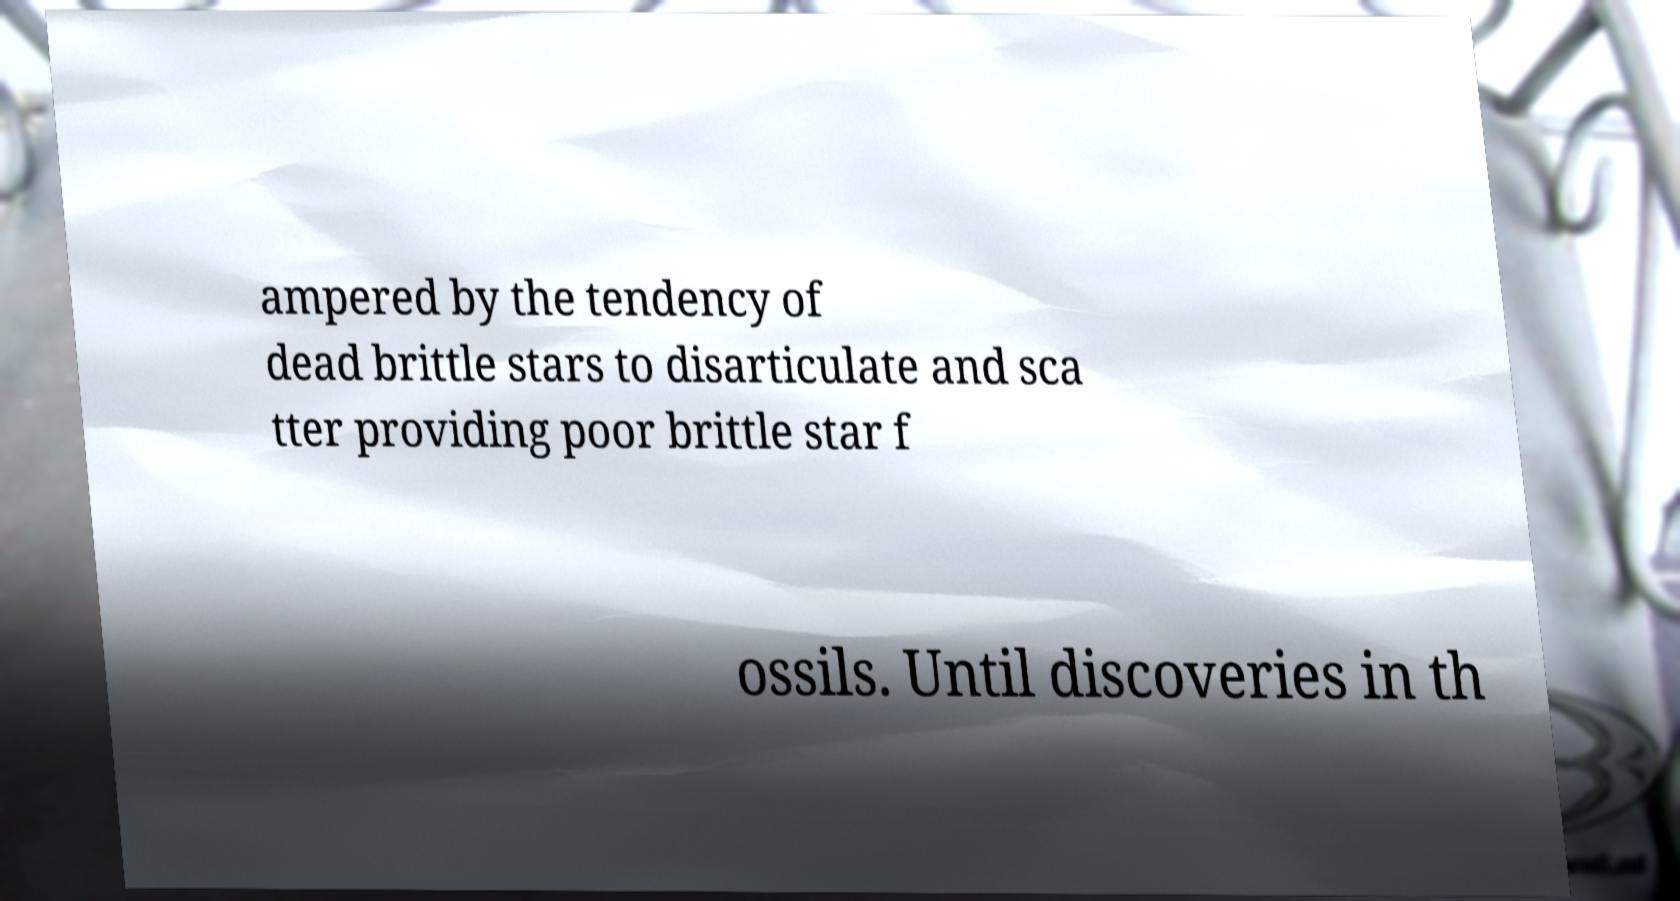Could you assist in decoding the text presented in this image and type it out clearly? ampered by the tendency of dead brittle stars to disarticulate and sca tter providing poor brittle star f ossils. Until discoveries in th 